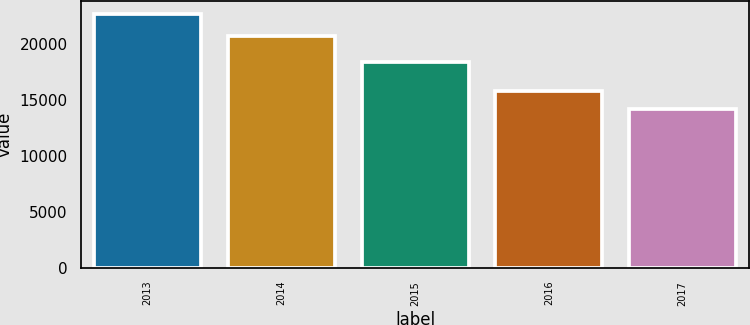Convert chart to OTSL. <chart><loc_0><loc_0><loc_500><loc_500><bar_chart><fcel>2013<fcel>2014<fcel>2015<fcel>2016<fcel>2017<nl><fcel>22715<fcel>20716<fcel>18421<fcel>15837<fcel>14207<nl></chart> 